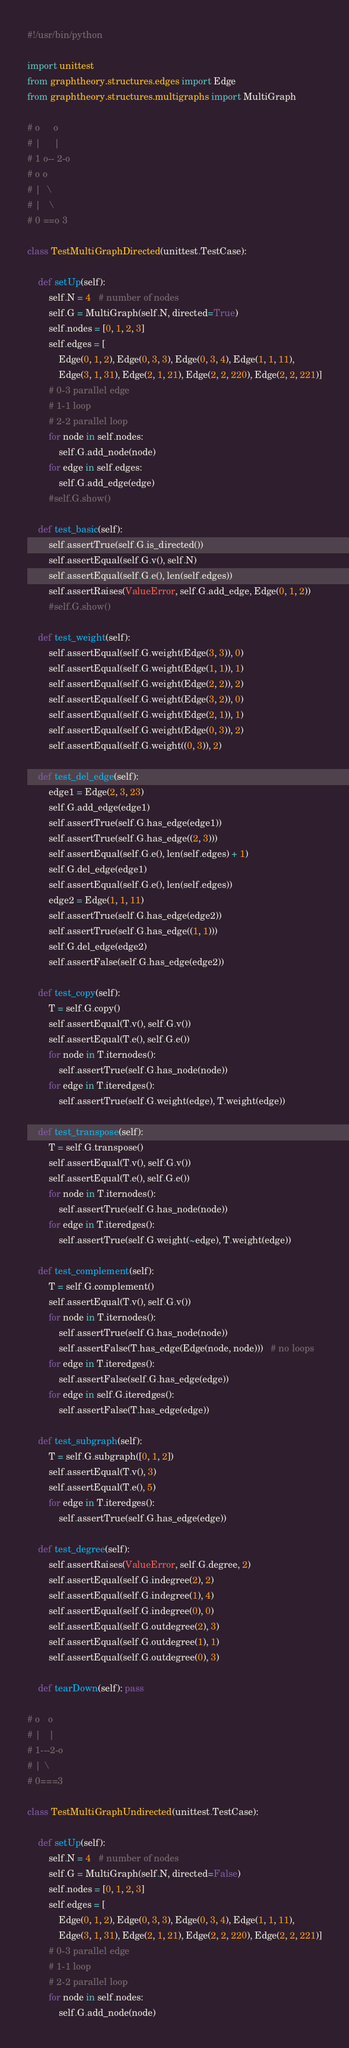Convert code to text. <code><loc_0><loc_0><loc_500><loc_500><_Python_>#!/usr/bin/python

import unittest
from graphtheory.structures.edges import Edge
from graphtheory.structures.multigraphs import MultiGraph

# o     o
# |     |
# 1 o-- 2-o
# o o
# |  \
# |   \
# 0 ==o 3

class TestMultiGraphDirected(unittest.TestCase):

    def setUp(self):
        self.N = 4   # number of nodes
        self.G = MultiGraph(self.N, directed=True)
        self.nodes = [0, 1, 2, 3]
        self.edges = [
            Edge(0, 1, 2), Edge(0, 3, 3), Edge(0, 3, 4), Edge(1, 1, 11), 
            Edge(3, 1, 31), Edge(2, 1, 21), Edge(2, 2, 220), Edge(2, 2, 221)]
        # 0-3 parallel edge
        # 1-1 loop
        # 2-2 parallel loop
        for node in self.nodes:
            self.G.add_node(node)
        for edge in self.edges:
            self.G.add_edge(edge)
        #self.G.show()

    def test_basic(self):
        self.assertTrue(self.G.is_directed())
        self.assertEqual(self.G.v(), self.N)
        self.assertEqual(self.G.e(), len(self.edges))
        self.assertRaises(ValueError, self.G.add_edge, Edge(0, 1, 2))
        #self.G.show()

    def test_weight(self):
        self.assertEqual(self.G.weight(Edge(3, 3)), 0)
        self.assertEqual(self.G.weight(Edge(1, 1)), 1)
        self.assertEqual(self.G.weight(Edge(2, 2)), 2)
        self.assertEqual(self.G.weight(Edge(3, 2)), 0)
        self.assertEqual(self.G.weight(Edge(2, 1)), 1)
        self.assertEqual(self.G.weight(Edge(0, 3)), 2)
        self.assertEqual(self.G.weight((0, 3)), 2)

    def test_del_edge(self):
        edge1 = Edge(2, 3, 23)
        self.G.add_edge(edge1)
        self.assertTrue(self.G.has_edge(edge1))
        self.assertTrue(self.G.has_edge((2, 3)))
        self.assertEqual(self.G.e(), len(self.edges) + 1)
        self.G.del_edge(edge1)
        self.assertEqual(self.G.e(), len(self.edges))
        edge2 = Edge(1, 1, 11)
        self.assertTrue(self.G.has_edge(edge2))
        self.assertTrue(self.G.has_edge((1, 1)))
        self.G.del_edge(edge2)
        self.assertFalse(self.G.has_edge(edge2))

    def test_copy(self):
        T = self.G.copy()
        self.assertEqual(T.v(), self.G.v())
        self.assertEqual(T.e(), self.G.e())
        for node in T.iternodes():
            self.assertTrue(self.G.has_node(node))
        for edge in T.iteredges():
            self.assertTrue(self.G.weight(edge), T.weight(edge))

    def test_transpose(self):
        T = self.G.transpose()
        self.assertEqual(T.v(), self.G.v())
        self.assertEqual(T.e(), self.G.e())
        for node in T.iternodes():
            self.assertTrue(self.G.has_node(node))
        for edge in T.iteredges():
            self.assertTrue(self.G.weight(~edge), T.weight(edge))

    def test_complement(self):
        T = self.G.complement()
        self.assertEqual(T.v(), self.G.v())
        for node in T.iternodes():
            self.assertTrue(self.G.has_node(node))
            self.assertFalse(T.has_edge(Edge(node, node)))   # no loops
        for edge in T.iteredges():
            self.assertFalse(self.G.has_edge(edge))
        for edge in self.G.iteredges():
            self.assertFalse(T.has_edge(edge))

    def test_subgraph(self):
        T = self.G.subgraph([0, 1, 2])
        self.assertEqual(T.v(), 3)
        self.assertEqual(T.e(), 5)
        for edge in T.iteredges():
            self.assertTrue(self.G.has_edge(edge))

    def test_degree(self):
        self.assertRaises(ValueError, self.G.degree, 2)
        self.assertEqual(self.G.indegree(2), 2)
        self.assertEqual(self.G.indegree(1), 4)
        self.assertEqual(self.G.indegree(0), 0)
        self.assertEqual(self.G.outdegree(2), 3)
        self.assertEqual(self.G.outdegree(1), 1)
        self.assertEqual(self.G.outdegree(0), 3)

    def tearDown(self): pass

# o   o
# |   |
# 1---2-o
# | \
# 0===3

class TestMultiGraphUndirected(unittest.TestCase):

    def setUp(self):
        self.N = 4   # number of nodes
        self.G = MultiGraph(self.N, directed=False)
        self.nodes = [0, 1, 2, 3]
        self.edges = [
            Edge(0, 1, 2), Edge(0, 3, 3), Edge(0, 3, 4), Edge(1, 1, 11), 
            Edge(3, 1, 31), Edge(2, 1, 21), Edge(2, 2, 220), Edge(2, 2, 221)]
        # 0-3 parallel edge
        # 1-1 loop
        # 2-2 parallel loop
        for node in self.nodes:
            self.G.add_node(node)</code> 